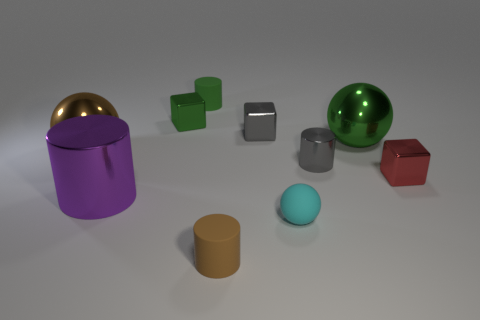How does the lighting in this scene affect the appearance of the objects? The lighting in this scene is soft and diffused, providing a gentle illumination that enhances the colours and materials of the objects. The shadows are soft-edged, giving the objects a three-dimensional appearance and enhancing their shapes. 